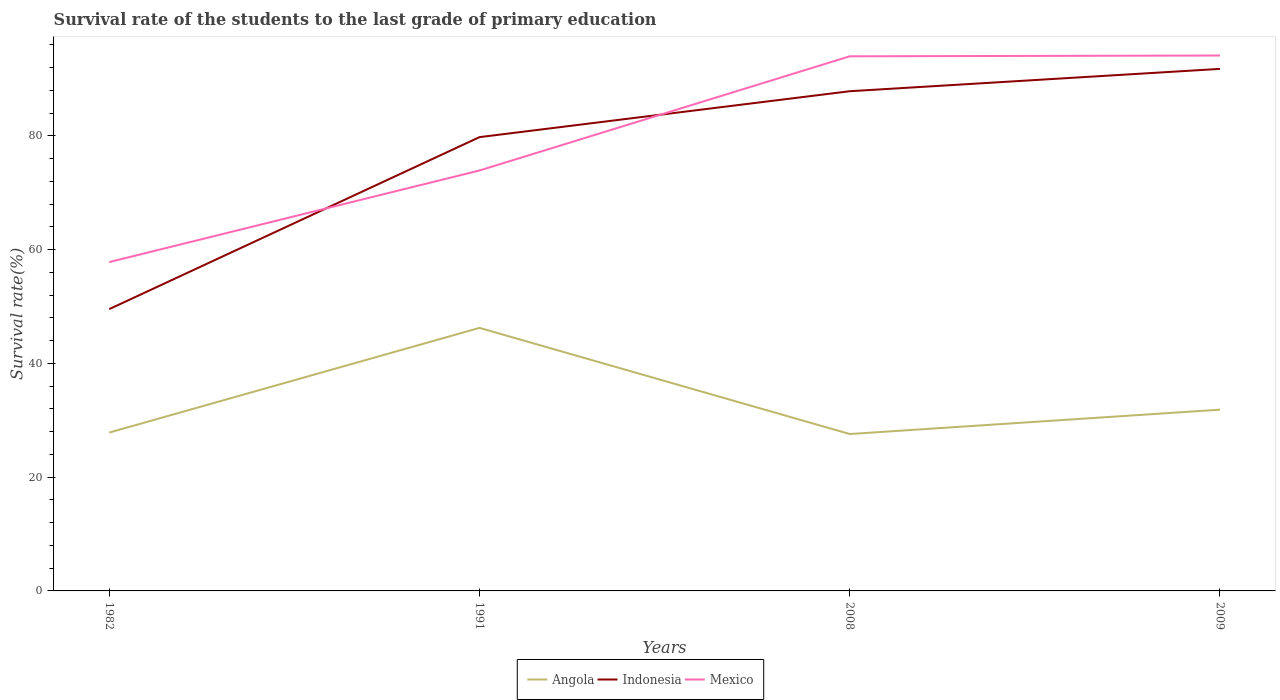Does the line corresponding to Indonesia intersect with the line corresponding to Angola?
Give a very brief answer. No. Across all years, what is the maximum survival rate of the students in Indonesia?
Provide a short and direct response. 49.55. In which year was the survival rate of the students in Mexico maximum?
Offer a terse response. 1982. What is the total survival rate of the students in Angola in the graph?
Keep it short and to the point. -18.41. What is the difference between the highest and the second highest survival rate of the students in Mexico?
Your answer should be very brief. 36.33. Is the survival rate of the students in Mexico strictly greater than the survival rate of the students in Angola over the years?
Your answer should be compact. No. Does the graph contain grids?
Provide a succinct answer. No. Where does the legend appear in the graph?
Ensure brevity in your answer.  Bottom center. What is the title of the graph?
Give a very brief answer. Survival rate of the students to the last grade of primary education. Does "Cambodia" appear as one of the legend labels in the graph?
Offer a terse response. No. What is the label or title of the X-axis?
Your answer should be compact. Years. What is the label or title of the Y-axis?
Make the answer very short. Survival rate(%). What is the Survival rate(%) of Angola in 1982?
Offer a terse response. 27.85. What is the Survival rate(%) of Indonesia in 1982?
Provide a succinct answer. 49.55. What is the Survival rate(%) of Mexico in 1982?
Keep it short and to the point. 57.83. What is the Survival rate(%) in Angola in 1991?
Your answer should be compact. 46.25. What is the Survival rate(%) in Indonesia in 1991?
Your answer should be very brief. 79.8. What is the Survival rate(%) in Mexico in 1991?
Make the answer very short. 73.93. What is the Survival rate(%) in Angola in 2008?
Make the answer very short. 27.59. What is the Survival rate(%) of Indonesia in 2008?
Ensure brevity in your answer.  87.87. What is the Survival rate(%) of Mexico in 2008?
Ensure brevity in your answer.  94.01. What is the Survival rate(%) in Angola in 2009?
Provide a short and direct response. 31.87. What is the Survival rate(%) in Indonesia in 2009?
Keep it short and to the point. 91.8. What is the Survival rate(%) of Mexico in 2009?
Your response must be concise. 94.15. Across all years, what is the maximum Survival rate(%) of Angola?
Ensure brevity in your answer.  46.25. Across all years, what is the maximum Survival rate(%) of Indonesia?
Give a very brief answer. 91.8. Across all years, what is the maximum Survival rate(%) of Mexico?
Your response must be concise. 94.15. Across all years, what is the minimum Survival rate(%) of Angola?
Make the answer very short. 27.59. Across all years, what is the minimum Survival rate(%) in Indonesia?
Offer a very short reply. 49.55. Across all years, what is the minimum Survival rate(%) in Mexico?
Keep it short and to the point. 57.83. What is the total Survival rate(%) of Angola in the graph?
Provide a short and direct response. 133.57. What is the total Survival rate(%) of Indonesia in the graph?
Make the answer very short. 309.02. What is the total Survival rate(%) of Mexico in the graph?
Your answer should be very brief. 319.92. What is the difference between the Survival rate(%) of Angola in 1982 and that in 1991?
Ensure brevity in your answer.  -18.41. What is the difference between the Survival rate(%) in Indonesia in 1982 and that in 1991?
Your response must be concise. -30.24. What is the difference between the Survival rate(%) of Mexico in 1982 and that in 1991?
Your answer should be compact. -16.11. What is the difference between the Survival rate(%) in Angola in 1982 and that in 2008?
Make the answer very short. 0.26. What is the difference between the Survival rate(%) of Indonesia in 1982 and that in 2008?
Your answer should be very brief. -38.32. What is the difference between the Survival rate(%) in Mexico in 1982 and that in 2008?
Provide a short and direct response. -36.18. What is the difference between the Survival rate(%) of Angola in 1982 and that in 2009?
Offer a very short reply. -4.02. What is the difference between the Survival rate(%) of Indonesia in 1982 and that in 2009?
Offer a very short reply. -42.25. What is the difference between the Survival rate(%) in Mexico in 1982 and that in 2009?
Provide a short and direct response. -36.33. What is the difference between the Survival rate(%) of Angola in 1991 and that in 2008?
Ensure brevity in your answer.  18.66. What is the difference between the Survival rate(%) of Indonesia in 1991 and that in 2008?
Your answer should be compact. -8.07. What is the difference between the Survival rate(%) of Mexico in 1991 and that in 2008?
Your answer should be very brief. -20.08. What is the difference between the Survival rate(%) of Angola in 1991 and that in 2009?
Provide a succinct answer. 14.38. What is the difference between the Survival rate(%) of Indonesia in 1991 and that in 2009?
Your answer should be very brief. -12. What is the difference between the Survival rate(%) of Mexico in 1991 and that in 2009?
Your answer should be compact. -20.22. What is the difference between the Survival rate(%) of Angola in 2008 and that in 2009?
Your answer should be compact. -4.28. What is the difference between the Survival rate(%) in Indonesia in 2008 and that in 2009?
Give a very brief answer. -3.93. What is the difference between the Survival rate(%) in Mexico in 2008 and that in 2009?
Ensure brevity in your answer.  -0.14. What is the difference between the Survival rate(%) of Angola in 1982 and the Survival rate(%) of Indonesia in 1991?
Your response must be concise. -51.95. What is the difference between the Survival rate(%) in Angola in 1982 and the Survival rate(%) in Mexico in 1991?
Make the answer very short. -46.08. What is the difference between the Survival rate(%) of Indonesia in 1982 and the Survival rate(%) of Mexico in 1991?
Give a very brief answer. -24.38. What is the difference between the Survival rate(%) in Angola in 1982 and the Survival rate(%) in Indonesia in 2008?
Provide a short and direct response. -60.02. What is the difference between the Survival rate(%) in Angola in 1982 and the Survival rate(%) in Mexico in 2008?
Offer a terse response. -66.16. What is the difference between the Survival rate(%) of Indonesia in 1982 and the Survival rate(%) of Mexico in 2008?
Provide a short and direct response. -44.46. What is the difference between the Survival rate(%) in Angola in 1982 and the Survival rate(%) in Indonesia in 2009?
Your response must be concise. -63.95. What is the difference between the Survival rate(%) of Angola in 1982 and the Survival rate(%) of Mexico in 2009?
Offer a terse response. -66.3. What is the difference between the Survival rate(%) of Indonesia in 1982 and the Survival rate(%) of Mexico in 2009?
Your answer should be very brief. -44.6. What is the difference between the Survival rate(%) of Angola in 1991 and the Survival rate(%) of Indonesia in 2008?
Provide a short and direct response. -41.62. What is the difference between the Survival rate(%) in Angola in 1991 and the Survival rate(%) in Mexico in 2008?
Make the answer very short. -47.76. What is the difference between the Survival rate(%) in Indonesia in 1991 and the Survival rate(%) in Mexico in 2008?
Provide a succinct answer. -14.21. What is the difference between the Survival rate(%) in Angola in 1991 and the Survival rate(%) in Indonesia in 2009?
Give a very brief answer. -45.55. What is the difference between the Survival rate(%) in Angola in 1991 and the Survival rate(%) in Mexico in 2009?
Ensure brevity in your answer.  -47.9. What is the difference between the Survival rate(%) in Indonesia in 1991 and the Survival rate(%) in Mexico in 2009?
Offer a terse response. -14.35. What is the difference between the Survival rate(%) in Angola in 2008 and the Survival rate(%) in Indonesia in 2009?
Make the answer very short. -64.21. What is the difference between the Survival rate(%) of Angola in 2008 and the Survival rate(%) of Mexico in 2009?
Your answer should be very brief. -66.56. What is the difference between the Survival rate(%) in Indonesia in 2008 and the Survival rate(%) in Mexico in 2009?
Keep it short and to the point. -6.28. What is the average Survival rate(%) of Angola per year?
Offer a terse response. 33.39. What is the average Survival rate(%) in Indonesia per year?
Provide a succinct answer. 77.25. What is the average Survival rate(%) of Mexico per year?
Offer a very short reply. 79.98. In the year 1982, what is the difference between the Survival rate(%) in Angola and Survival rate(%) in Indonesia?
Ensure brevity in your answer.  -21.7. In the year 1982, what is the difference between the Survival rate(%) of Angola and Survival rate(%) of Mexico?
Offer a terse response. -29.98. In the year 1982, what is the difference between the Survival rate(%) of Indonesia and Survival rate(%) of Mexico?
Provide a succinct answer. -8.27. In the year 1991, what is the difference between the Survival rate(%) of Angola and Survival rate(%) of Indonesia?
Provide a short and direct response. -33.54. In the year 1991, what is the difference between the Survival rate(%) in Angola and Survival rate(%) in Mexico?
Make the answer very short. -27.68. In the year 1991, what is the difference between the Survival rate(%) in Indonesia and Survival rate(%) in Mexico?
Offer a terse response. 5.87. In the year 2008, what is the difference between the Survival rate(%) in Angola and Survival rate(%) in Indonesia?
Offer a very short reply. -60.28. In the year 2008, what is the difference between the Survival rate(%) of Angola and Survival rate(%) of Mexico?
Provide a succinct answer. -66.42. In the year 2008, what is the difference between the Survival rate(%) of Indonesia and Survival rate(%) of Mexico?
Your response must be concise. -6.14. In the year 2009, what is the difference between the Survival rate(%) of Angola and Survival rate(%) of Indonesia?
Offer a very short reply. -59.93. In the year 2009, what is the difference between the Survival rate(%) in Angola and Survival rate(%) in Mexico?
Your answer should be very brief. -62.28. In the year 2009, what is the difference between the Survival rate(%) of Indonesia and Survival rate(%) of Mexico?
Your answer should be very brief. -2.35. What is the ratio of the Survival rate(%) in Angola in 1982 to that in 1991?
Provide a succinct answer. 0.6. What is the ratio of the Survival rate(%) in Indonesia in 1982 to that in 1991?
Give a very brief answer. 0.62. What is the ratio of the Survival rate(%) of Mexico in 1982 to that in 1991?
Your answer should be compact. 0.78. What is the ratio of the Survival rate(%) in Angola in 1982 to that in 2008?
Offer a terse response. 1.01. What is the ratio of the Survival rate(%) in Indonesia in 1982 to that in 2008?
Your answer should be compact. 0.56. What is the ratio of the Survival rate(%) in Mexico in 1982 to that in 2008?
Give a very brief answer. 0.62. What is the ratio of the Survival rate(%) in Angola in 1982 to that in 2009?
Your answer should be compact. 0.87. What is the ratio of the Survival rate(%) in Indonesia in 1982 to that in 2009?
Make the answer very short. 0.54. What is the ratio of the Survival rate(%) of Mexico in 1982 to that in 2009?
Provide a short and direct response. 0.61. What is the ratio of the Survival rate(%) of Angola in 1991 to that in 2008?
Provide a short and direct response. 1.68. What is the ratio of the Survival rate(%) in Indonesia in 1991 to that in 2008?
Your answer should be compact. 0.91. What is the ratio of the Survival rate(%) of Mexico in 1991 to that in 2008?
Give a very brief answer. 0.79. What is the ratio of the Survival rate(%) of Angola in 1991 to that in 2009?
Ensure brevity in your answer.  1.45. What is the ratio of the Survival rate(%) in Indonesia in 1991 to that in 2009?
Your answer should be compact. 0.87. What is the ratio of the Survival rate(%) of Mexico in 1991 to that in 2009?
Make the answer very short. 0.79. What is the ratio of the Survival rate(%) of Angola in 2008 to that in 2009?
Ensure brevity in your answer.  0.87. What is the ratio of the Survival rate(%) of Indonesia in 2008 to that in 2009?
Provide a short and direct response. 0.96. What is the ratio of the Survival rate(%) in Mexico in 2008 to that in 2009?
Ensure brevity in your answer.  1. What is the difference between the highest and the second highest Survival rate(%) of Angola?
Provide a short and direct response. 14.38. What is the difference between the highest and the second highest Survival rate(%) in Indonesia?
Keep it short and to the point. 3.93. What is the difference between the highest and the second highest Survival rate(%) of Mexico?
Ensure brevity in your answer.  0.14. What is the difference between the highest and the lowest Survival rate(%) of Angola?
Your answer should be compact. 18.66. What is the difference between the highest and the lowest Survival rate(%) of Indonesia?
Your answer should be very brief. 42.25. What is the difference between the highest and the lowest Survival rate(%) of Mexico?
Give a very brief answer. 36.33. 